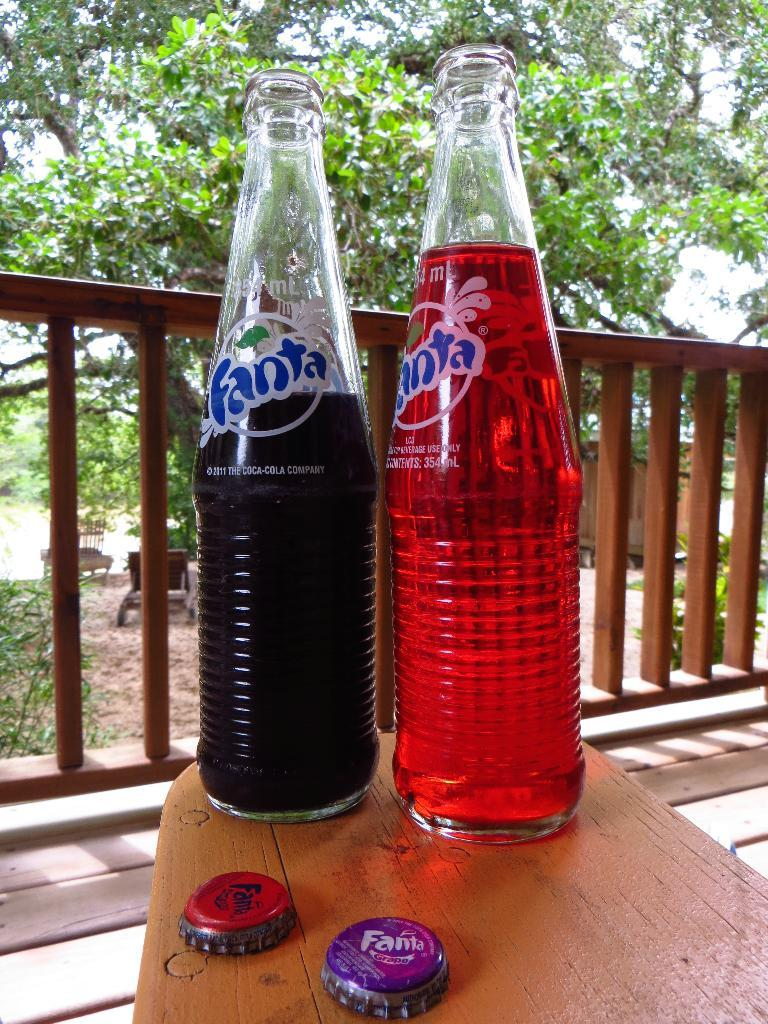<image>
Render a clear and concise summary of the photo. Two open bottles of Fanta cola sit on the armrest of a wooden deck chair. 